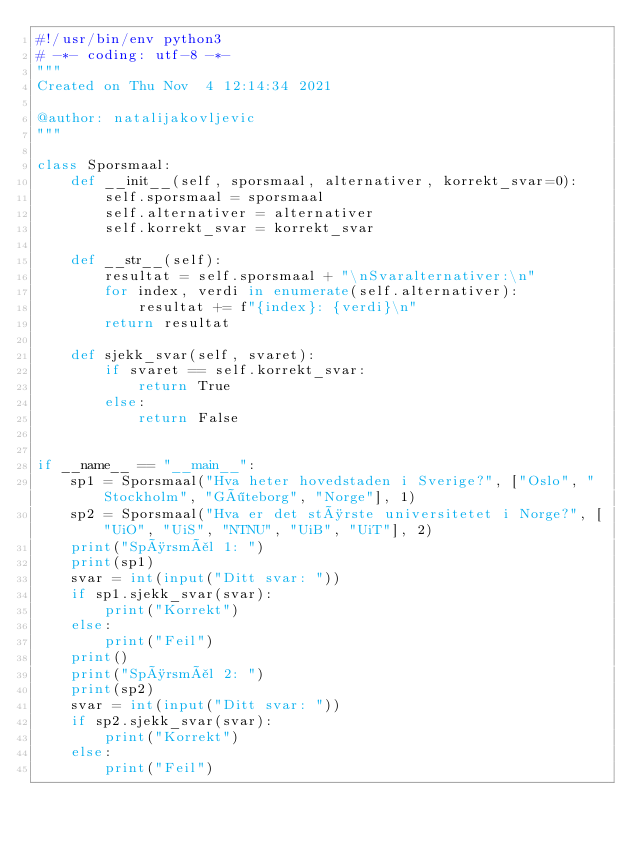Convert code to text. <code><loc_0><loc_0><loc_500><loc_500><_Python_>#!/usr/bin/env python3
# -*- coding: utf-8 -*-
"""
Created on Thu Nov  4 12:14:34 2021

@author: natalijakovljevic
"""

class Sporsmaal:
    def __init__(self, sporsmaal, alternativer, korrekt_svar=0):
        self.sporsmaal = sporsmaal
        self.alternativer = alternativer
        self.korrekt_svar = korrekt_svar
        
    def __str__(self):
        resultat = self.sporsmaal + "\nSvaralternativer:\n"
        for index, verdi in enumerate(self.alternativer):
            resultat += f"{index}: {verdi}\n"
        return resultat
    
    def sjekk_svar(self, svaret):
        if svaret == self.korrekt_svar:
            return True
        else:
            return False
        

if __name__ == "__main__":
    sp1 = Sporsmaal("Hva heter hovedstaden i Sverige?", ["Oslo", "Stockholm", "Göteborg", "Norge"], 1)
    sp2 = Sporsmaal("Hva er det største universitetet i Norge?", ["UiO", "UiS", "NTNU", "UiB", "UiT"], 2)
    print("Spørsmål 1: ")
    print(sp1)
    svar = int(input("Ditt svar: "))
    if sp1.sjekk_svar(svar):
        print("Korrekt")
    else:
        print("Feil")
    print()
    print("Spørsmål 2: ")
    print(sp2)
    svar = int(input("Ditt svar: "))
    if sp2.sjekk_svar(svar):
        print("Korrekt")
    else:
        print("Feil")
</code> 